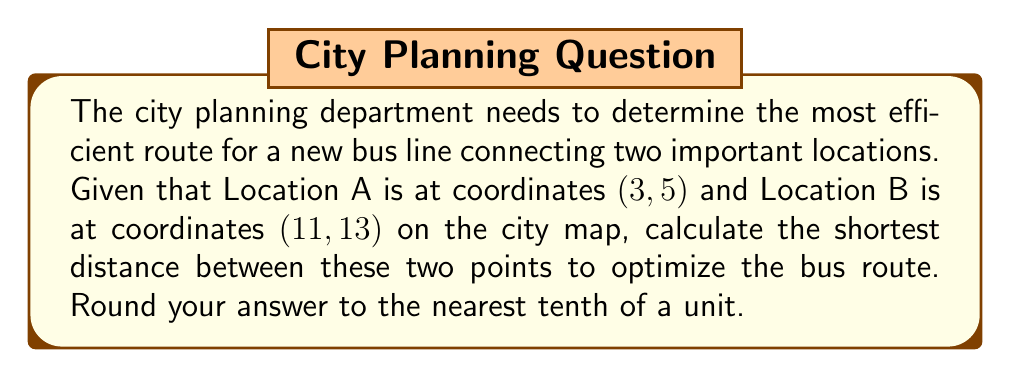Help me with this question. To find the shortest distance between two points on a coordinate plane, we use the distance formula, which is derived from the Pythagorean theorem:

$$d = \sqrt{(x_2 - x_1)^2 + (y_2 - y_1)^2}$$

Where:
$(x_1, y_1)$ represents the coordinates of the first point (Location A)
$(x_2, y_2)$ represents the coordinates of the second point (Location B)

Let's plug in our values:
$(x_1, y_1) = (3, 5)$
$(x_2, y_2) = (11, 13)$

Now, let's calculate step by step:

1) Substitute the values into the formula:
   $$d = \sqrt{(11 - 3)^2 + (13 - 5)^2}$$

2) Simplify inside the parentheses:
   $$d = \sqrt{8^2 + 8^2}$$

3) Calculate the squares:
   $$d = \sqrt{64 + 64}$$

4) Add inside the square root:
   $$d = \sqrt{128}$$

5) Simplify the square root:
   $$d = 8\sqrt{2}$$

6) Use a calculator to approximate and round to the nearest tenth:
   $$d \approx 11.3$$

Therefore, the shortest distance between Location A and Location B is approximately 11.3 units on the city map.
Answer: 11.3 units 